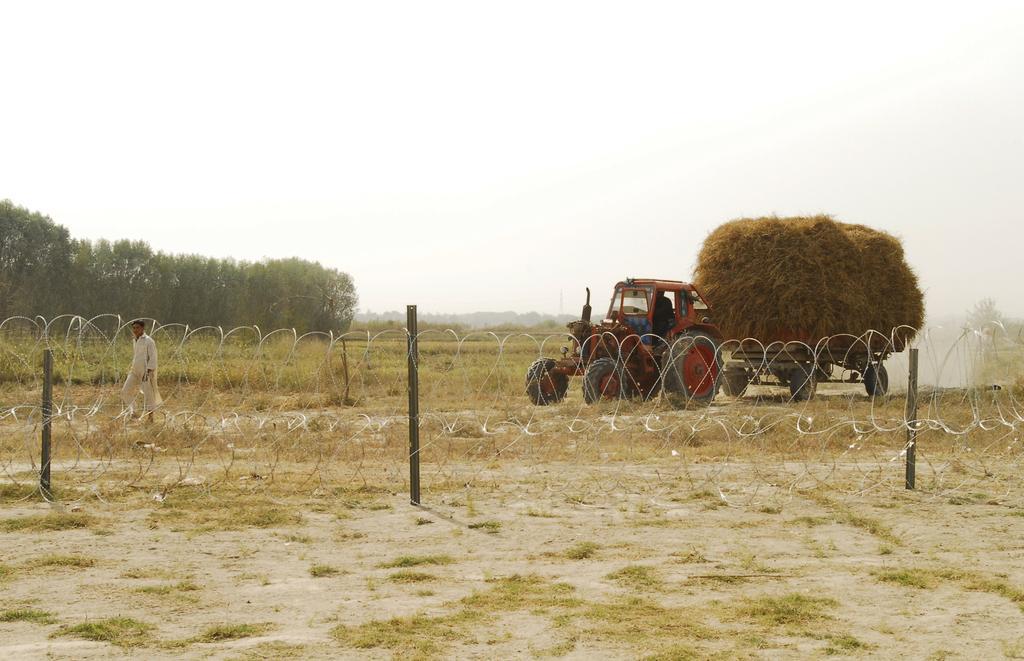Describe this image in one or two sentences. In this picture we can see some grass on the ground. There are a few poles and a wire fence being visible from left to right. We can see a person walking on the path. There is a grass on a tractor. We can see a few trees in the background. 